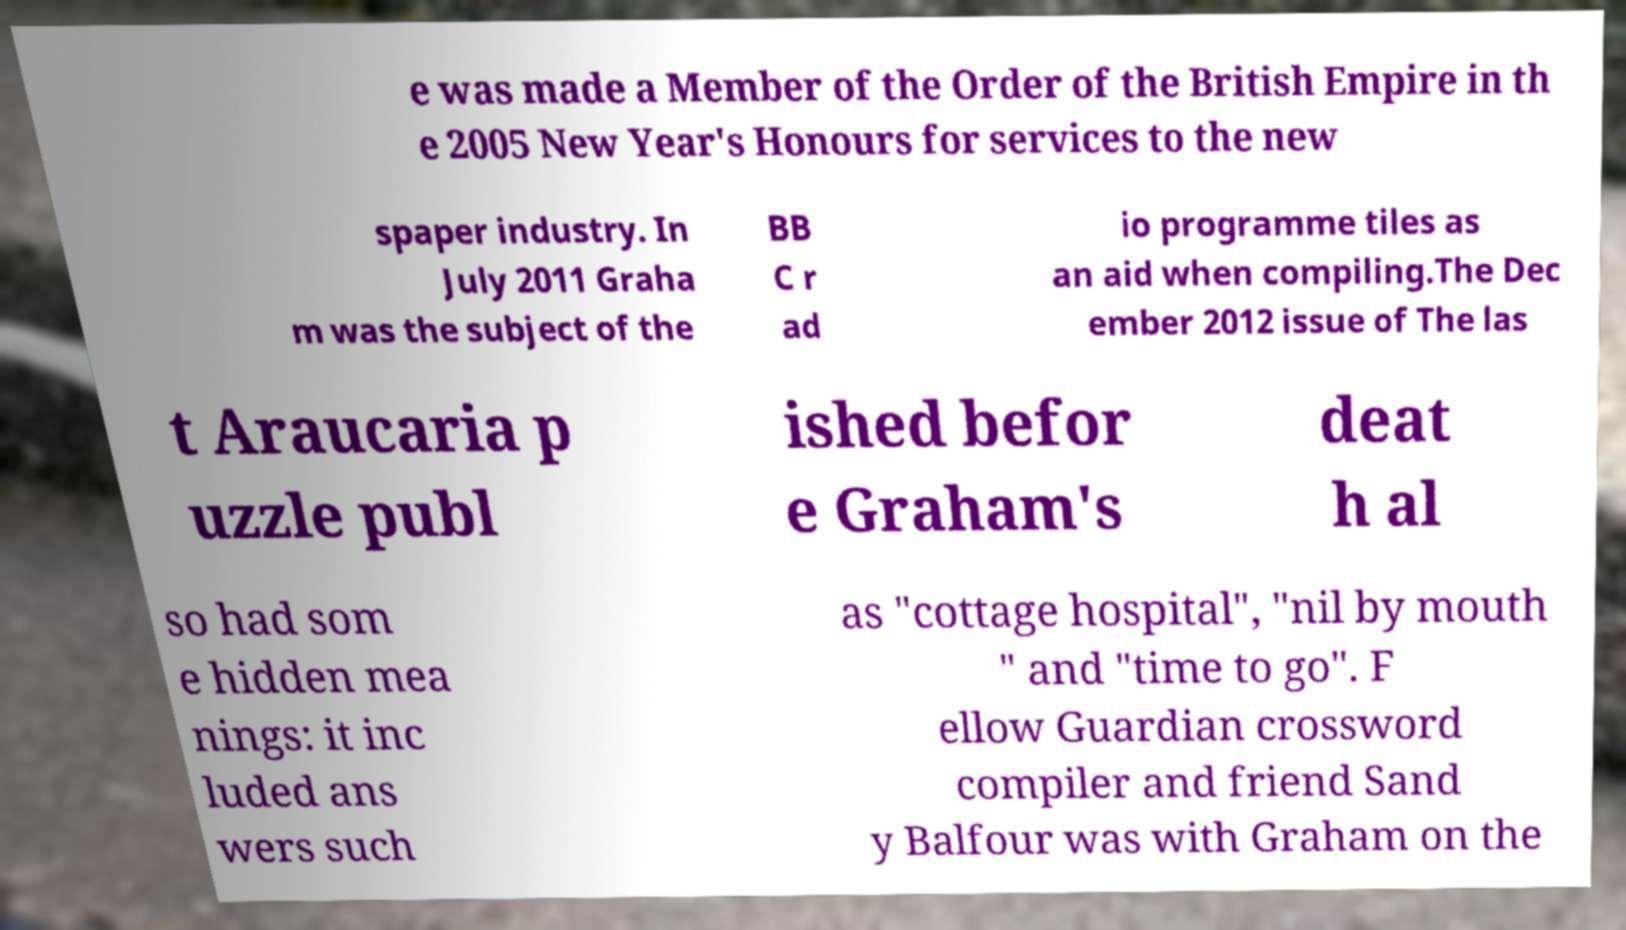Can you accurately transcribe the text from the provided image for me? e was made a Member of the Order of the British Empire in th e 2005 New Year's Honours for services to the new spaper industry. In July 2011 Graha m was the subject of the BB C r ad io programme tiles as an aid when compiling.The Dec ember 2012 issue of The las t Araucaria p uzzle publ ished befor e Graham's deat h al so had som e hidden mea nings: it inc luded ans wers such as "cottage hospital", "nil by mouth " and "time to go". F ellow Guardian crossword compiler and friend Sand y Balfour was with Graham on the 